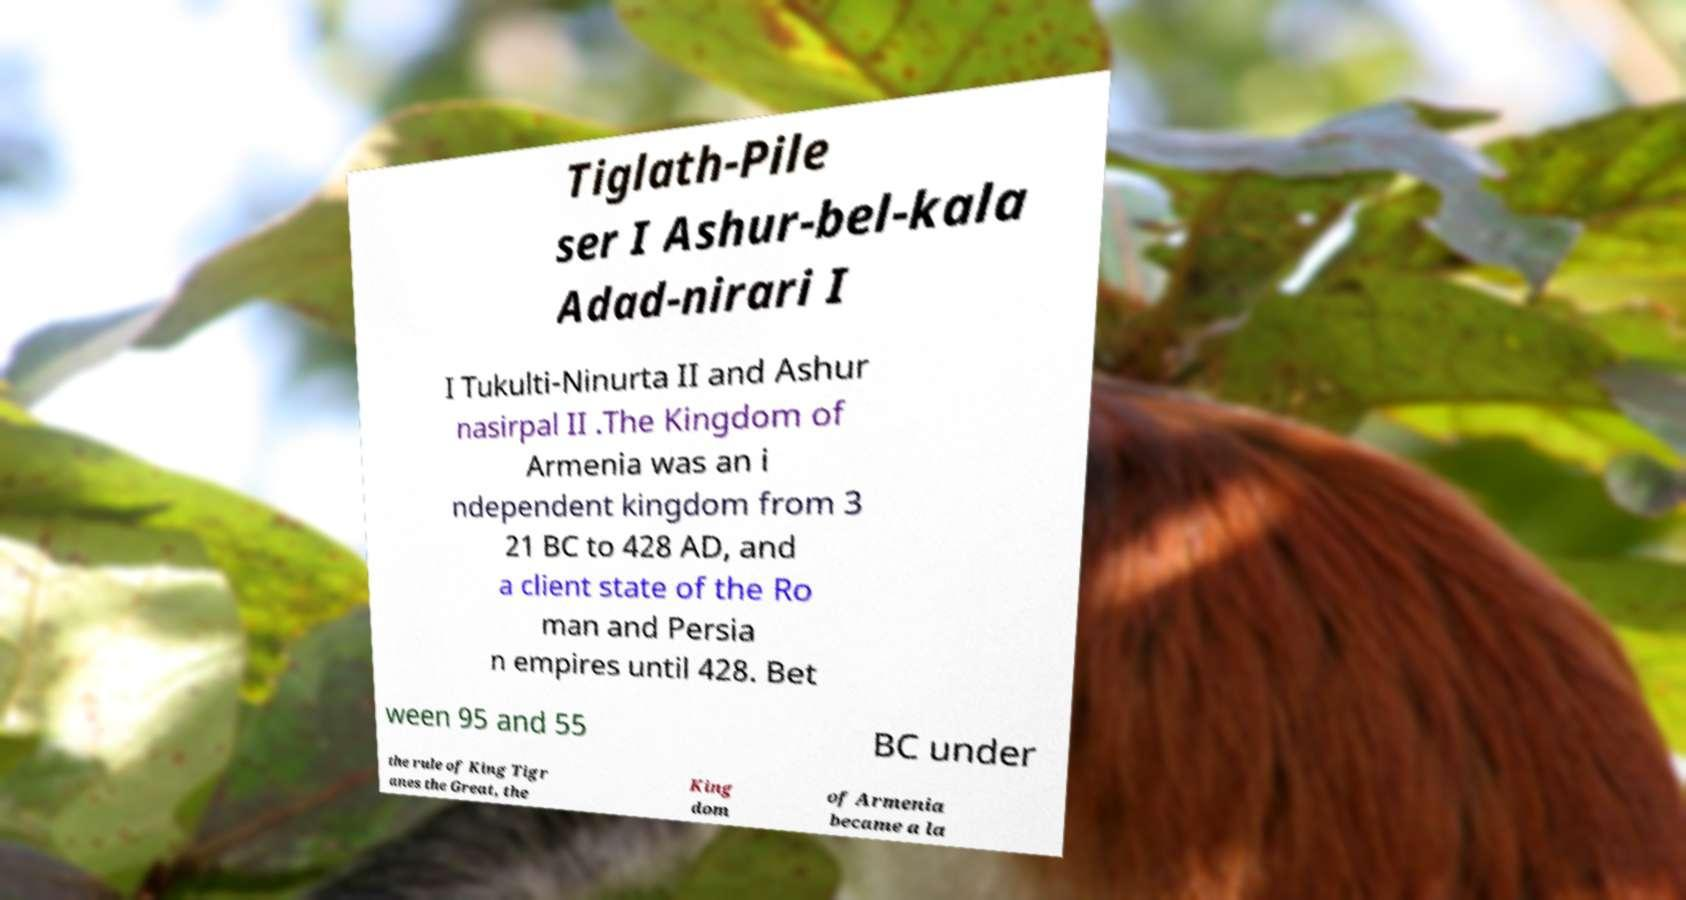What messages or text are displayed in this image? I need them in a readable, typed format. Tiglath-Pile ser I Ashur-bel-kala Adad-nirari I I Tukulti-Ninurta II and Ashur nasirpal II .The Kingdom of Armenia was an i ndependent kingdom from 3 21 BC to 428 AD, and a client state of the Ro man and Persia n empires until 428. Bet ween 95 and 55 BC under the rule of King Tigr anes the Great, the King dom of Armenia became a la 